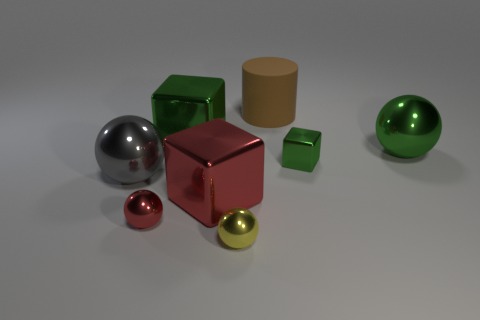Can you describe the different materials that the objects appear to be made of? Certainly. The objects appear to have varying material properties. The two spheres and the larger cube have reflective surfaces, suggesting they are metallic. One sphere has a chrome look, while the other is green and appears to be reflective as well. The smaller objects, two cubes, and a ball seem to have matte finishes, suggesting a possible plastic or painted surface. The cylinder has a matte, non-reflective surface too, which could be akin to cardboard or matte plastic. 